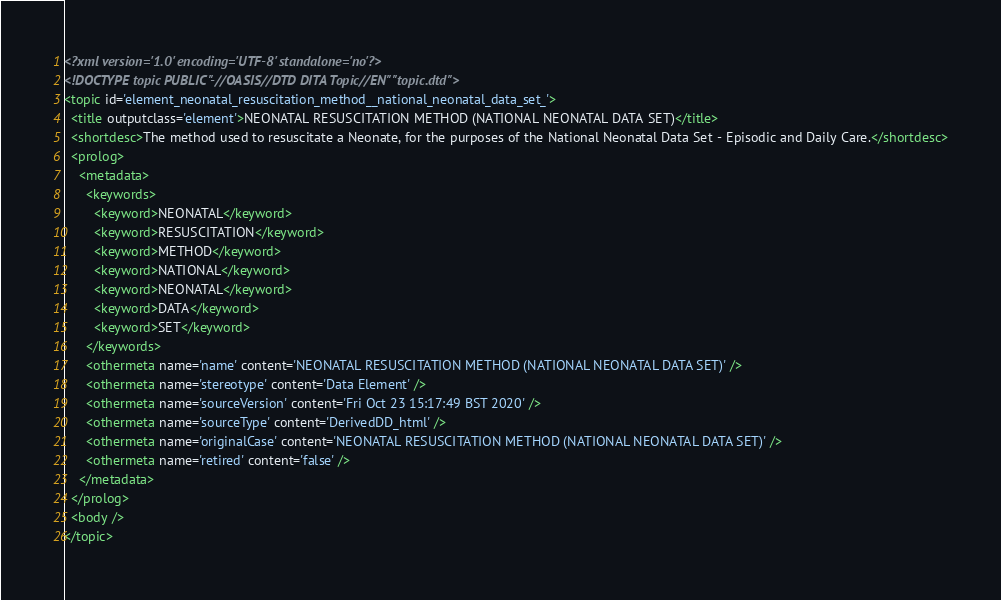<code> <loc_0><loc_0><loc_500><loc_500><_XML_><?xml version='1.0' encoding='UTF-8' standalone='no'?>
<!DOCTYPE topic PUBLIC "-//OASIS//DTD DITA Topic//EN" "topic.dtd">
<topic id='element_neonatal_resuscitation_method__national_neonatal_data_set_'>
  <title outputclass='element'>NEONATAL RESUSCITATION METHOD (NATIONAL NEONATAL DATA SET)</title>
  <shortdesc>The method used to resuscitate a Neonate, for the purposes of the National Neonatal Data Set - Episodic and Daily Care.</shortdesc>
  <prolog>
    <metadata>
      <keywords>
        <keyword>NEONATAL</keyword>
        <keyword>RESUSCITATION</keyword>
        <keyword>METHOD</keyword>
        <keyword>NATIONAL</keyword>
        <keyword>NEONATAL</keyword>
        <keyword>DATA</keyword>
        <keyword>SET</keyword>
      </keywords>
      <othermeta name='name' content='NEONATAL RESUSCITATION METHOD (NATIONAL NEONATAL DATA SET)' />
      <othermeta name='stereotype' content='Data Element' />
      <othermeta name='sourceVersion' content='Fri Oct 23 15:17:49 BST 2020' />
      <othermeta name='sourceType' content='DerivedDD_html' />
      <othermeta name='originalCase' content='NEONATAL RESUSCITATION METHOD (NATIONAL NEONATAL DATA SET)' />
      <othermeta name='retired' content='false' />
    </metadata>
  </prolog>
  <body />
</topic></code> 